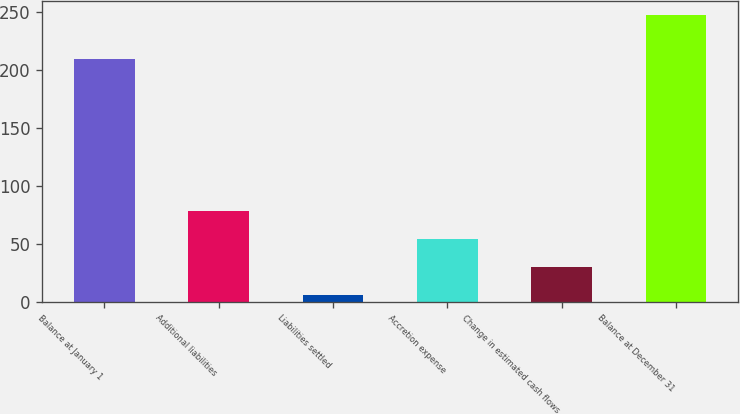Convert chart to OTSL. <chart><loc_0><loc_0><loc_500><loc_500><bar_chart><fcel>Balance at January 1<fcel>Additional liabilities<fcel>Liabilities settled<fcel>Accretion expense<fcel>Change in estimated cash flows<fcel>Balance at December 31<nl><fcel>209<fcel>78.3<fcel>6<fcel>54.2<fcel>30.1<fcel>247<nl></chart> 